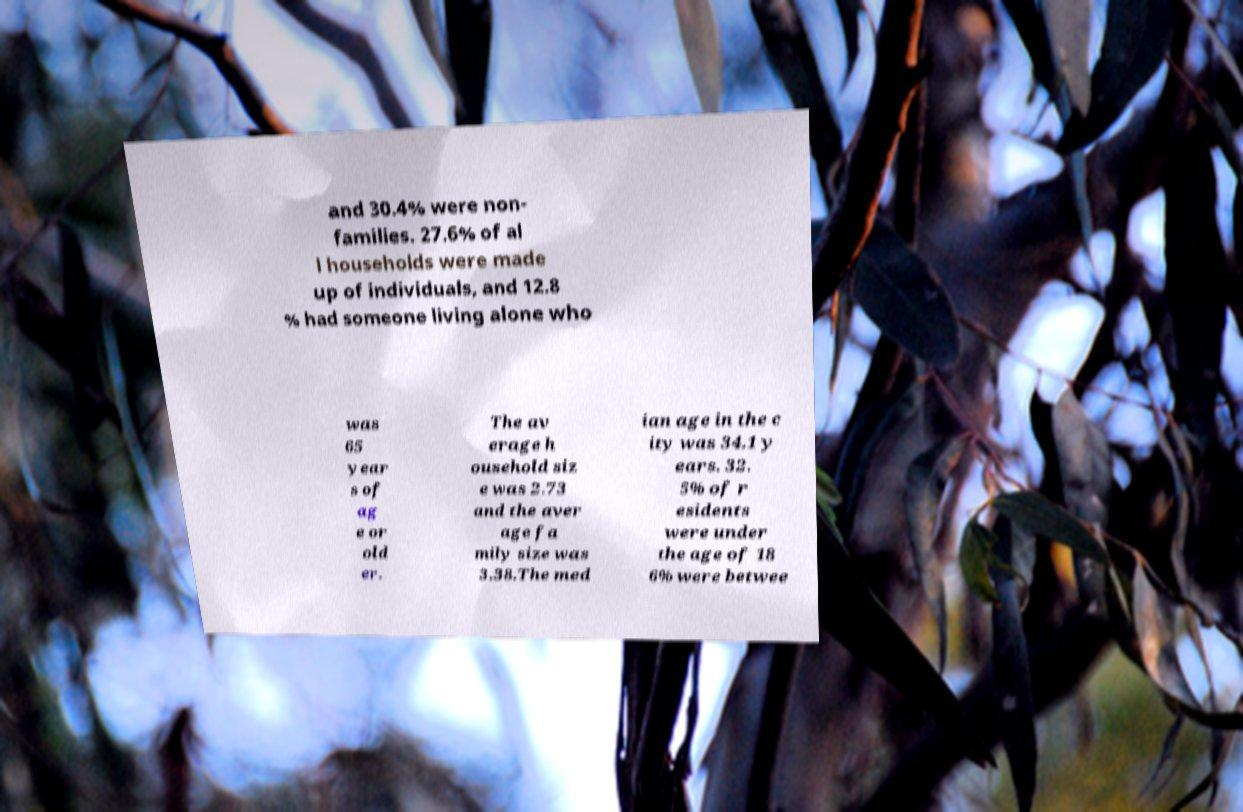There's text embedded in this image that I need extracted. Can you transcribe it verbatim? and 30.4% were non- families. 27.6% of al l households were made up of individuals, and 12.8 % had someone living alone who was 65 year s of ag e or old er. The av erage h ousehold siz e was 2.73 and the aver age fa mily size was 3.38.The med ian age in the c ity was 34.1 y ears. 32. 5% of r esidents were under the age of 18 6% were betwee 